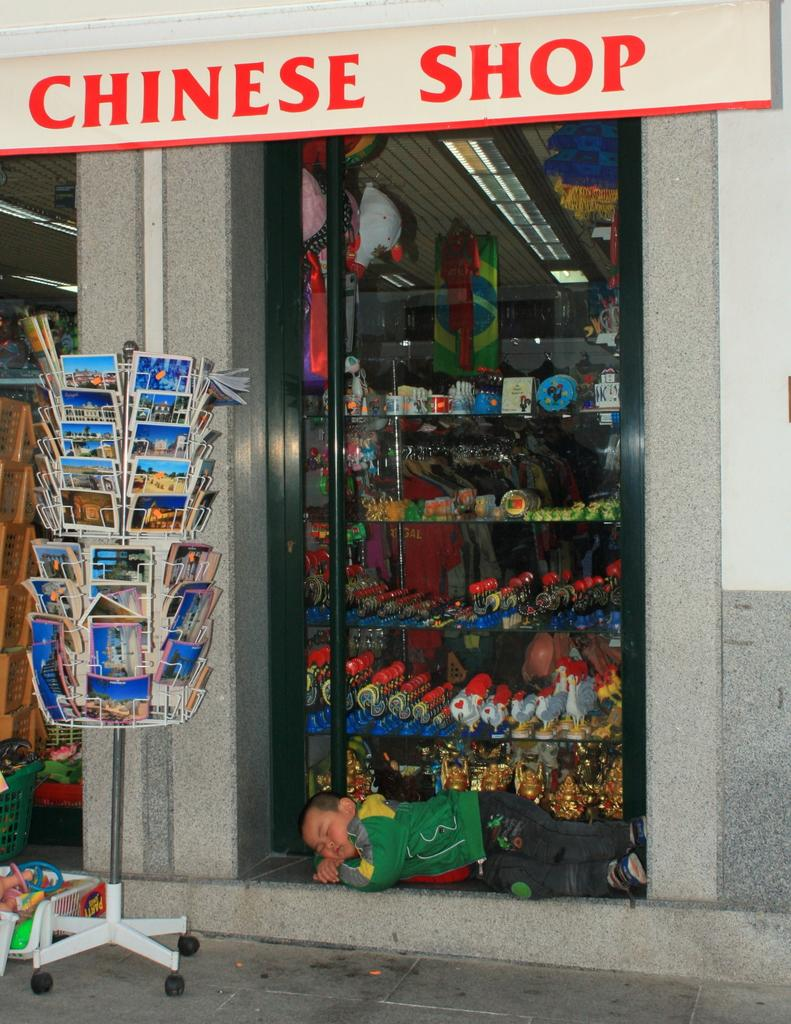<image>
Provide a brief description of the given image. Outside of store with a sign that reads Chinese Shop is a small boy asleep on the ground by the window. 